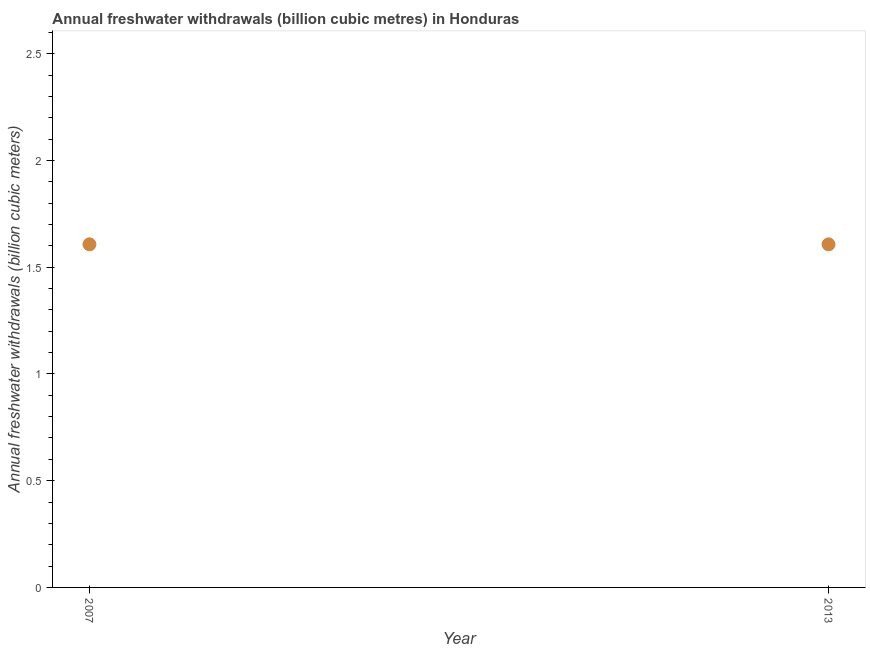What is the annual freshwater withdrawals in 2013?
Offer a very short reply. 1.61. Across all years, what is the maximum annual freshwater withdrawals?
Offer a very short reply. 1.61. Across all years, what is the minimum annual freshwater withdrawals?
Offer a terse response. 1.61. In which year was the annual freshwater withdrawals maximum?
Your answer should be very brief. 2007. In which year was the annual freshwater withdrawals minimum?
Make the answer very short. 2007. What is the sum of the annual freshwater withdrawals?
Offer a very short reply. 3.21. What is the difference between the annual freshwater withdrawals in 2007 and 2013?
Keep it short and to the point. 0. What is the average annual freshwater withdrawals per year?
Offer a terse response. 1.61. What is the median annual freshwater withdrawals?
Give a very brief answer. 1.61. In how many years, is the annual freshwater withdrawals greater than 2.1 billion cubic meters?
Offer a very short reply. 0. Do a majority of the years between 2013 and 2007 (inclusive) have annual freshwater withdrawals greater than 1.8 billion cubic meters?
Keep it short and to the point. No. Is the annual freshwater withdrawals in 2007 less than that in 2013?
Your response must be concise. No. In how many years, is the annual freshwater withdrawals greater than the average annual freshwater withdrawals taken over all years?
Give a very brief answer. 0. Does the annual freshwater withdrawals monotonically increase over the years?
Give a very brief answer. No. How many years are there in the graph?
Ensure brevity in your answer.  2. Are the values on the major ticks of Y-axis written in scientific E-notation?
Your answer should be very brief. No. Does the graph contain any zero values?
Make the answer very short. No. Does the graph contain grids?
Ensure brevity in your answer.  No. What is the title of the graph?
Offer a terse response. Annual freshwater withdrawals (billion cubic metres) in Honduras. What is the label or title of the Y-axis?
Give a very brief answer. Annual freshwater withdrawals (billion cubic meters). What is the Annual freshwater withdrawals (billion cubic meters) in 2007?
Provide a succinct answer. 1.61. What is the Annual freshwater withdrawals (billion cubic meters) in 2013?
Your response must be concise. 1.61. What is the difference between the Annual freshwater withdrawals (billion cubic meters) in 2007 and 2013?
Offer a very short reply. 0. What is the ratio of the Annual freshwater withdrawals (billion cubic meters) in 2007 to that in 2013?
Keep it short and to the point. 1. 